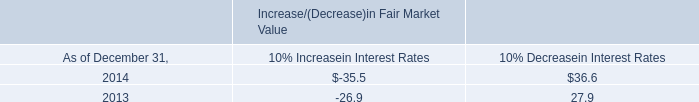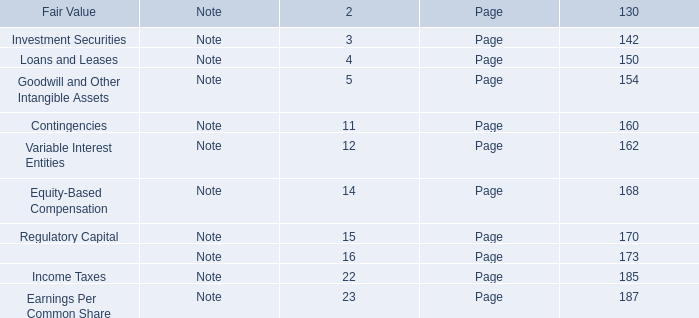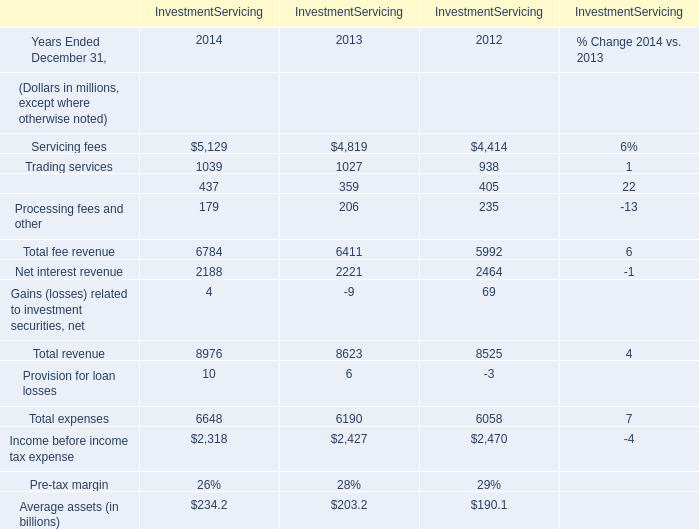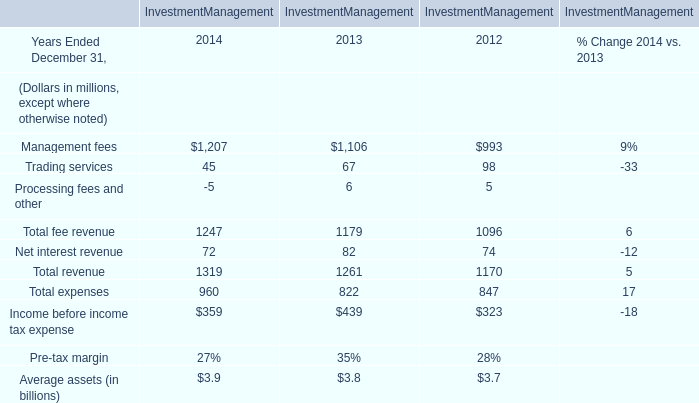What was the total amount of the Total revenue in the years where Total fee revenue is greater than 6500? (in million) 
Computations: (((((5129 + 1039) + 437) + 179) + 2188) + 4)
Answer: 8976.0. 